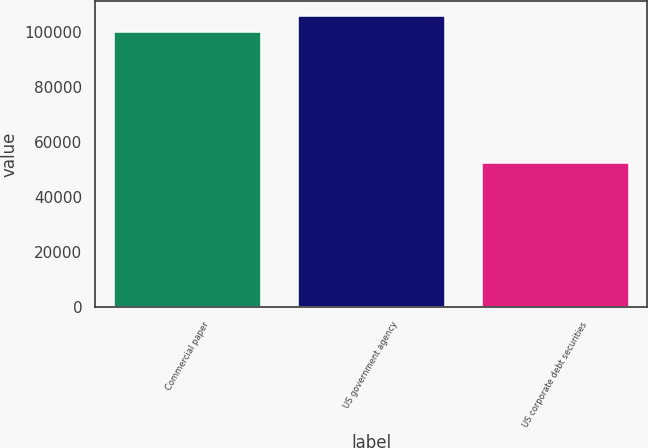<chart> <loc_0><loc_0><loc_500><loc_500><bar_chart><fcel>Commercial paper<fcel>US government agency<fcel>US corporate debt securities<nl><fcel>100149<fcel>106021<fcel>52312<nl></chart> 